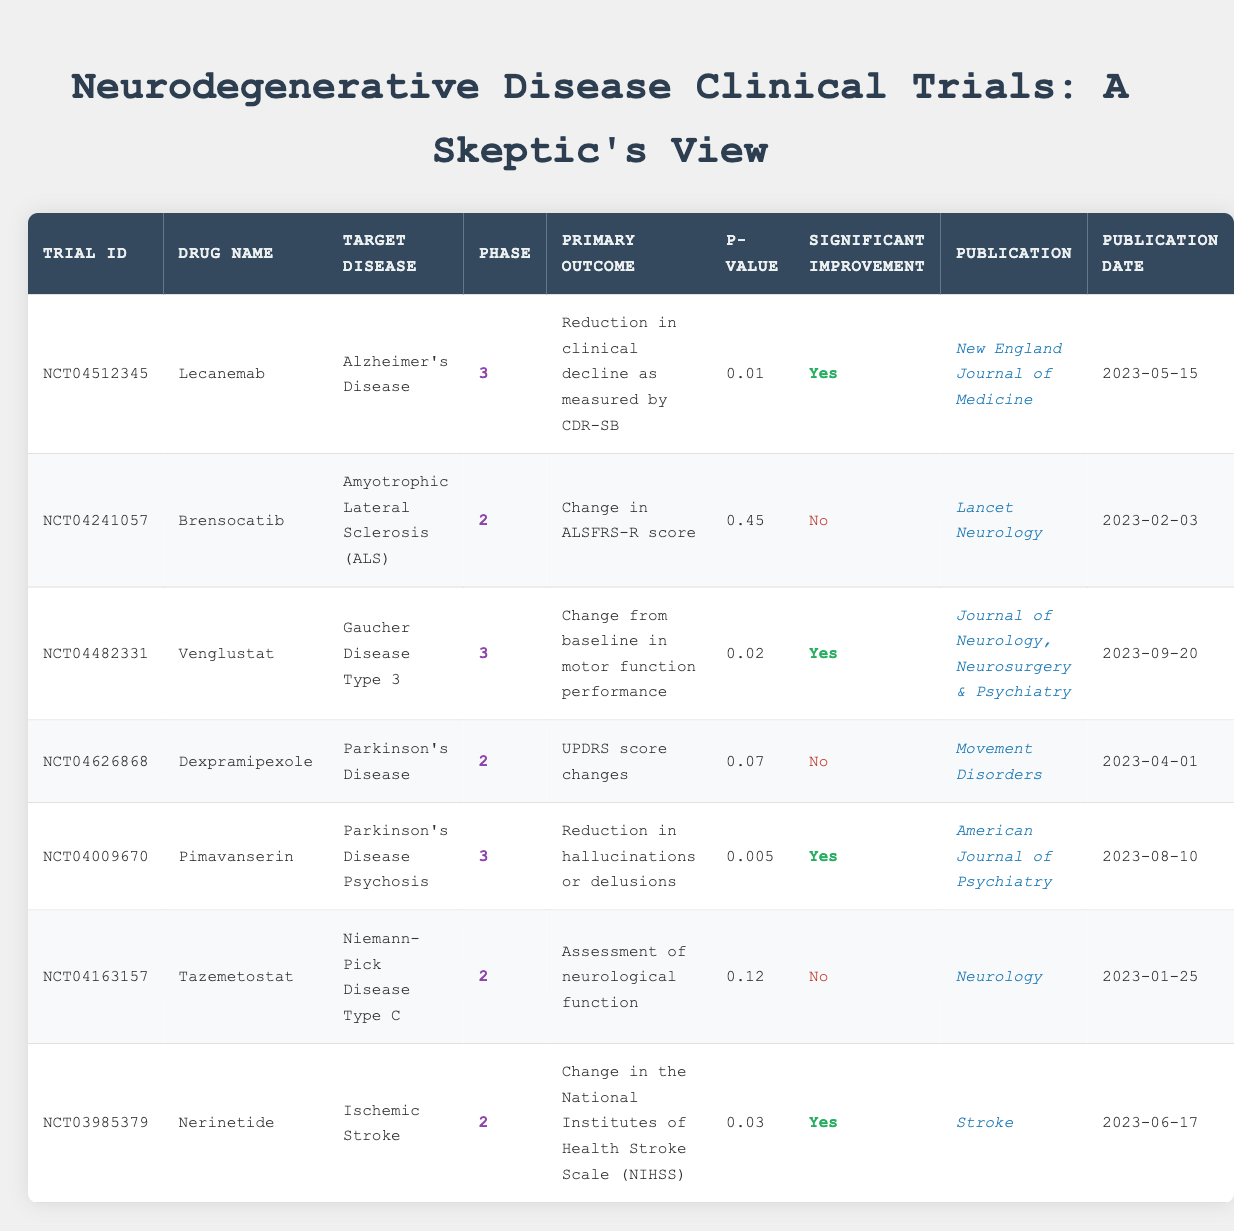What is the drug name associated with the trial ID NCT04512345? The trial ID NCT04512345 corresponds to the drug Lecanemab, which is listed in the table under the "Drug Name" column.
Answer: Lecanemab How many trials focused on Parkinson's Disease? There are three trials listed in the table that target Parkinson's Disease, specifically Dexpramipexole and Pimavanserin, along with their respective data.
Answer: 2 Which drug achieved significant improvement with a p-value less than 0.01? The drug Pimavanserin achieved significant improvement with a p-value of 0.005, as indicated in the results summary.
Answer: Pimavanserin What is the publication date for the trial of Venglustat? The publication date for the trial of Venglustat (NCT04482331) can be found in the table, and it is listed as September 20, 2023.
Answer: 2023-09-20 Did the trial of Brensocatib show significant improvement? The results for Brensocatib indicate a p-value of 0.45, and it is explicitly labeled as "No" for significant improvement, as stated in the summary.
Answer: No What is the average p-value of the trials listed? To find the average p-value, add all the p-values (0.01 + 0.45 + 0.02 + 0.07 + 0.005 + 0.12 + 0.03) = 0.712, then divide by 7 (the number of trials) giving an average of approximately 0.1017.
Answer: 0.1017 Is there any trial that has a publication in the American Journal of Psychiatry? Yes, the trial for drug Pimavanserin is published in the American Journal of Psychiatry, according to the publication column.
Answer: Yes Which trial had the primary outcome related to hallucinations or delusions? The trial for Pimavanserin had the primary outcome focused on the reduction in hallucinations or delusions, as indicated in the primary outcome column.
Answer: Pimavanserin 